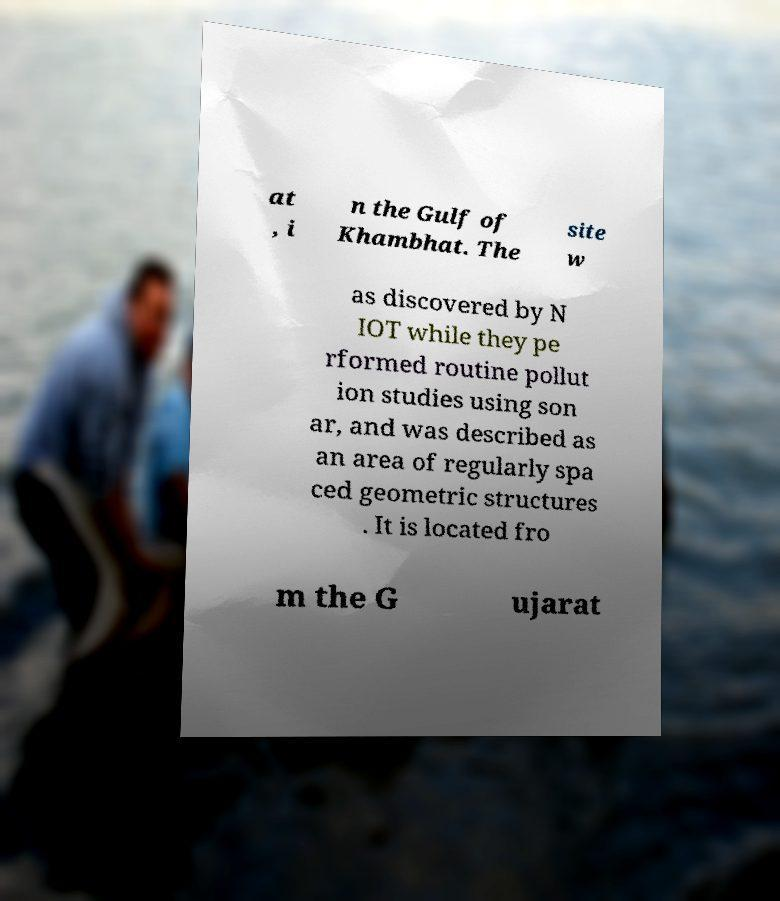Please identify and transcribe the text found in this image. at , i n the Gulf of Khambhat. The site w as discovered by N IOT while they pe rformed routine pollut ion studies using son ar, and was described as an area of regularly spa ced geometric structures . It is located fro m the G ujarat 